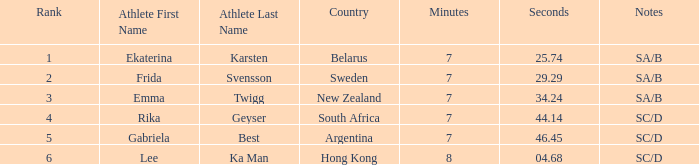What is the total rank for the athlete that had a race time of 7:34.24? 1.0. 